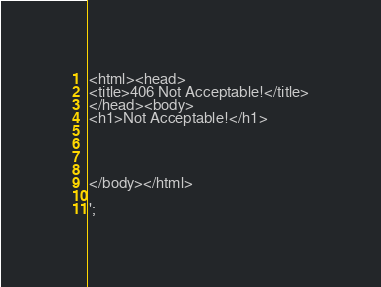Convert code to text. <code><loc_0><loc_0><loc_500><loc_500><_PHP_><html><head>
<title>406 Not Acceptable!</title>
</head><body>
<h1>Not Acceptable!</h1>




</body></html>

';</code> 